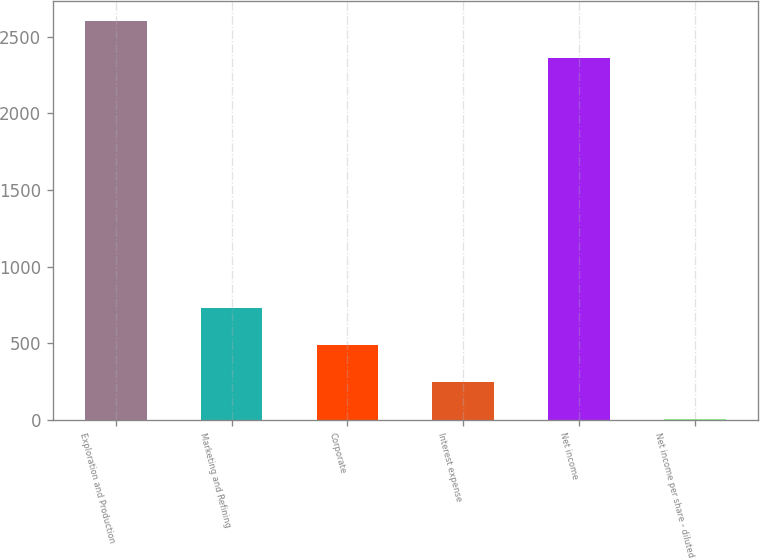Convert chart. <chart><loc_0><loc_0><loc_500><loc_500><bar_chart><fcel>Exploration and Production<fcel>Marketing and Refining<fcel>Corporate<fcel>Interest expense<fcel>Net income<fcel>Net income per share - diluted<nl><fcel>2601.58<fcel>731.98<fcel>490.4<fcel>248.82<fcel>2360<fcel>7.24<nl></chart> 